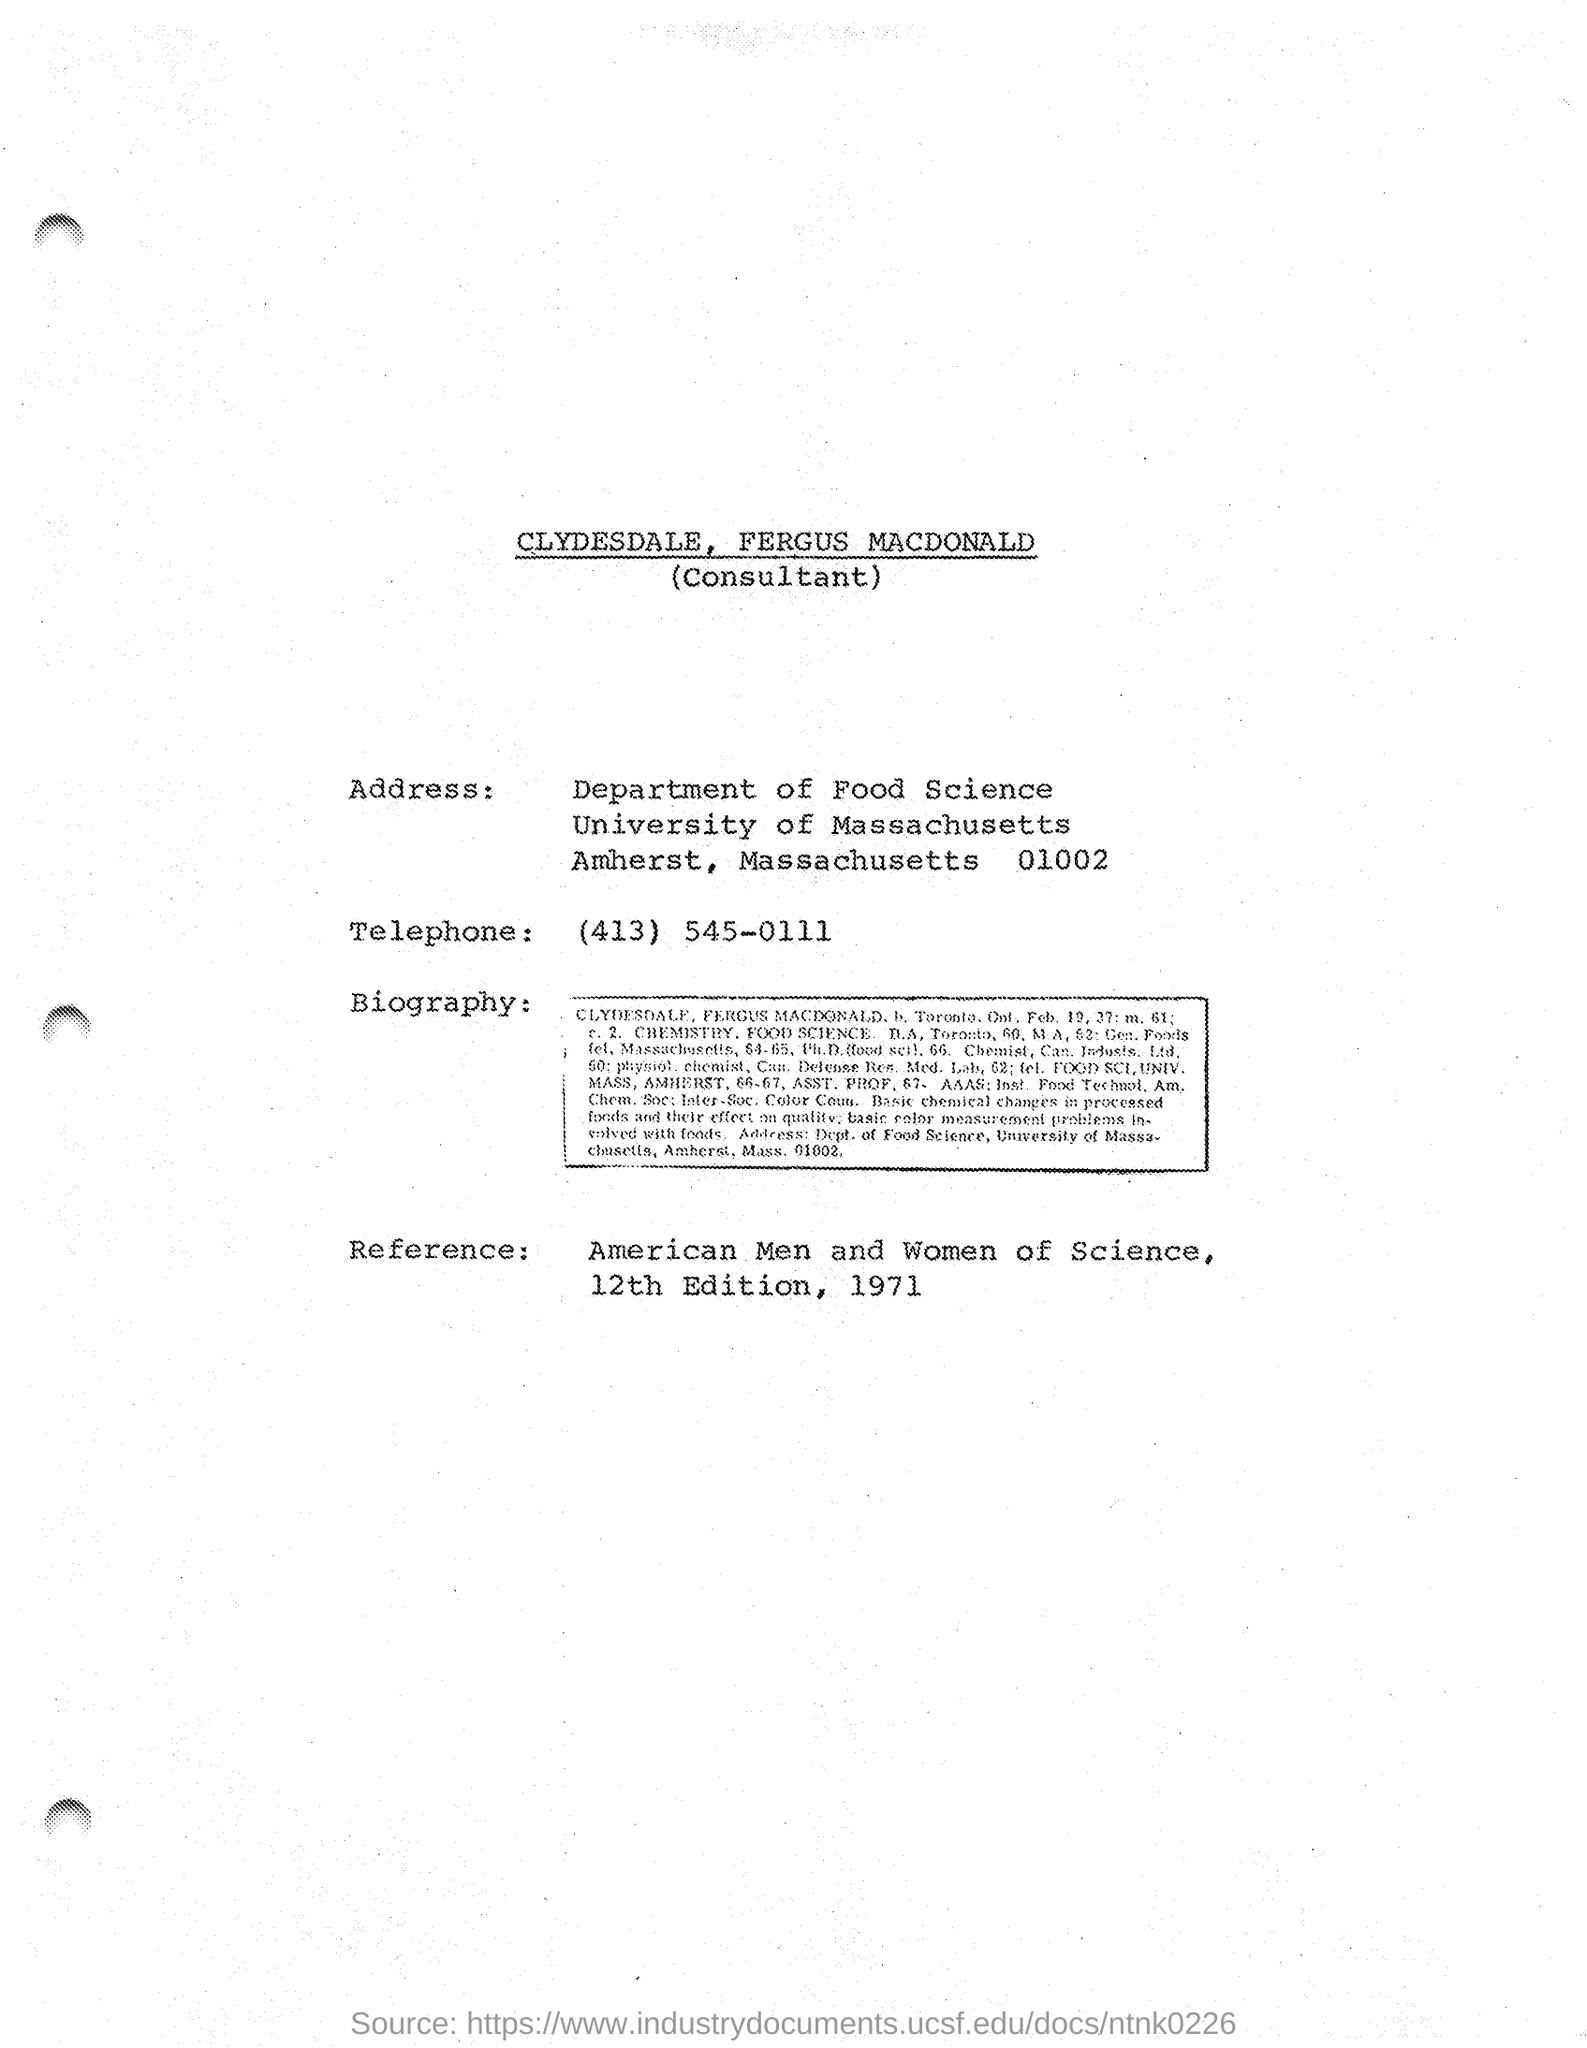What is the telephone number mentioned in the given page ?
Keep it short and to the point. (413) 545-0111. What is the name of university mentioned in the given address
Ensure brevity in your answer.  University of massachusetts. What is the reference mentioned in the given page ?
Offer a very short reply. American men and women of science. 